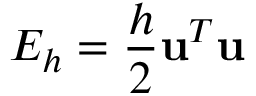<formula> <loc_0><loc_0><loc_500><loc_500>E _ { h } = \frac { h } { 2 } u ^ { T } u</formula> 